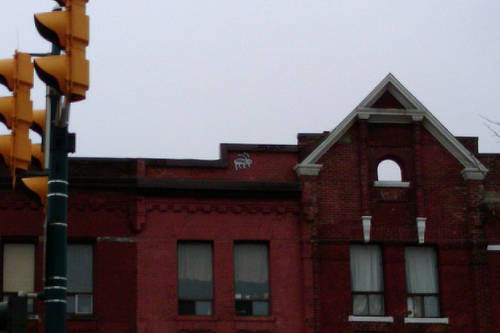<image>
Can you confirm if the arch is above the window? Yes. The arch is positioned above the window in the vertical space, higher up in the scene. 